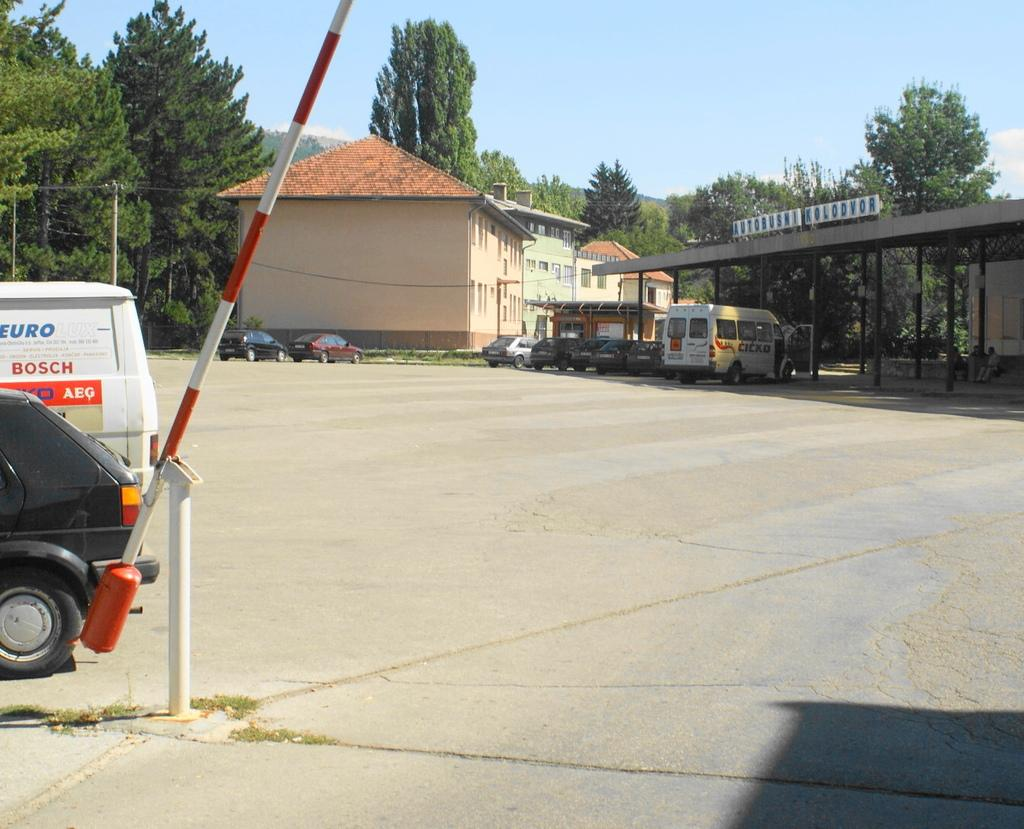What can be seen in the left corner of the image? There are two vehicles in the left corner of the image. What is visible in the background of the image? There are buildings, vehicles, and trees in the background of the image. What type of twig is being used as a toy by the cub in the image? There is no cub or twig present in the image. What sense is being stimulated by the image? The image does not stimulate a specific sense; it is a visual representation. 